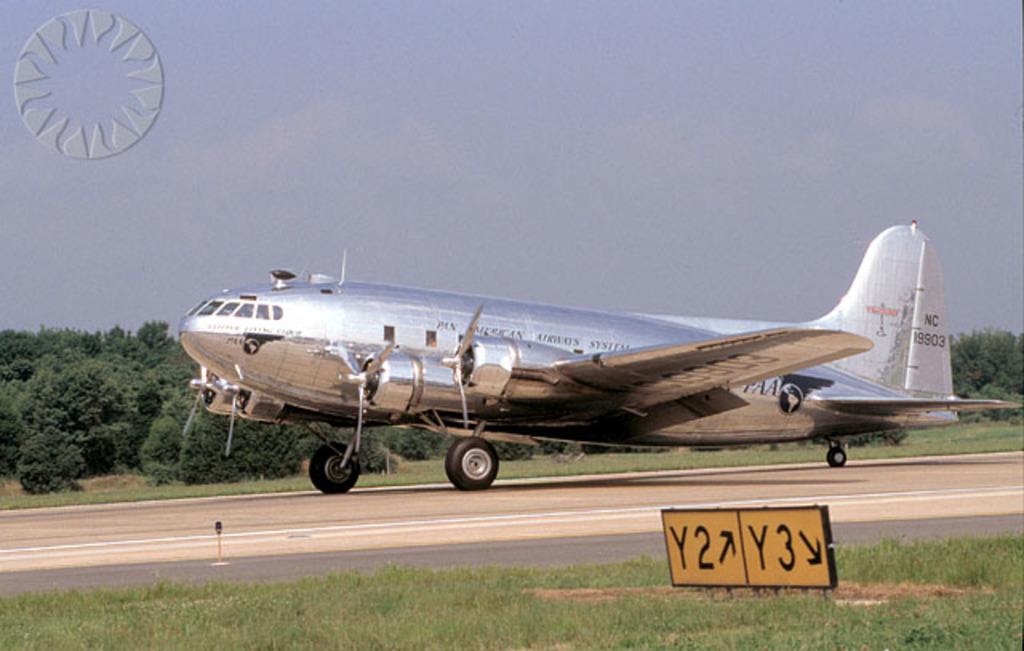What is on the orange sign near the plane?
Make the answer very short. Y2 y3. 